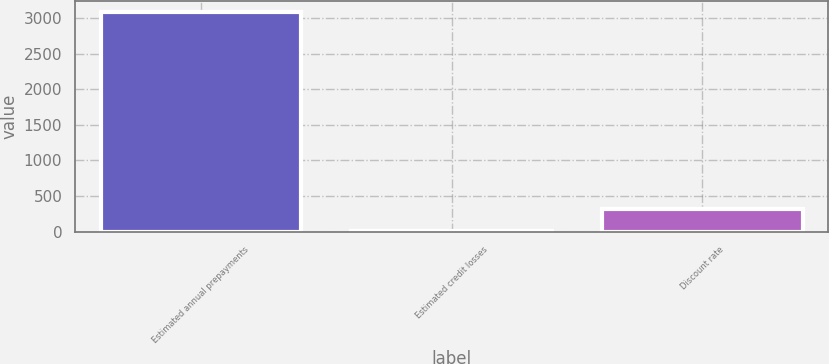Convert chart. <chart><loc_0><loc_0><loc_500><loc_500><bar_chart><fcel>Estimated annual prepayments<fcel>Estimated credit losses<fcel>Discount rate<nl><fcel>3090<fcel>3.6<fcel>312.24<nl></chart> 